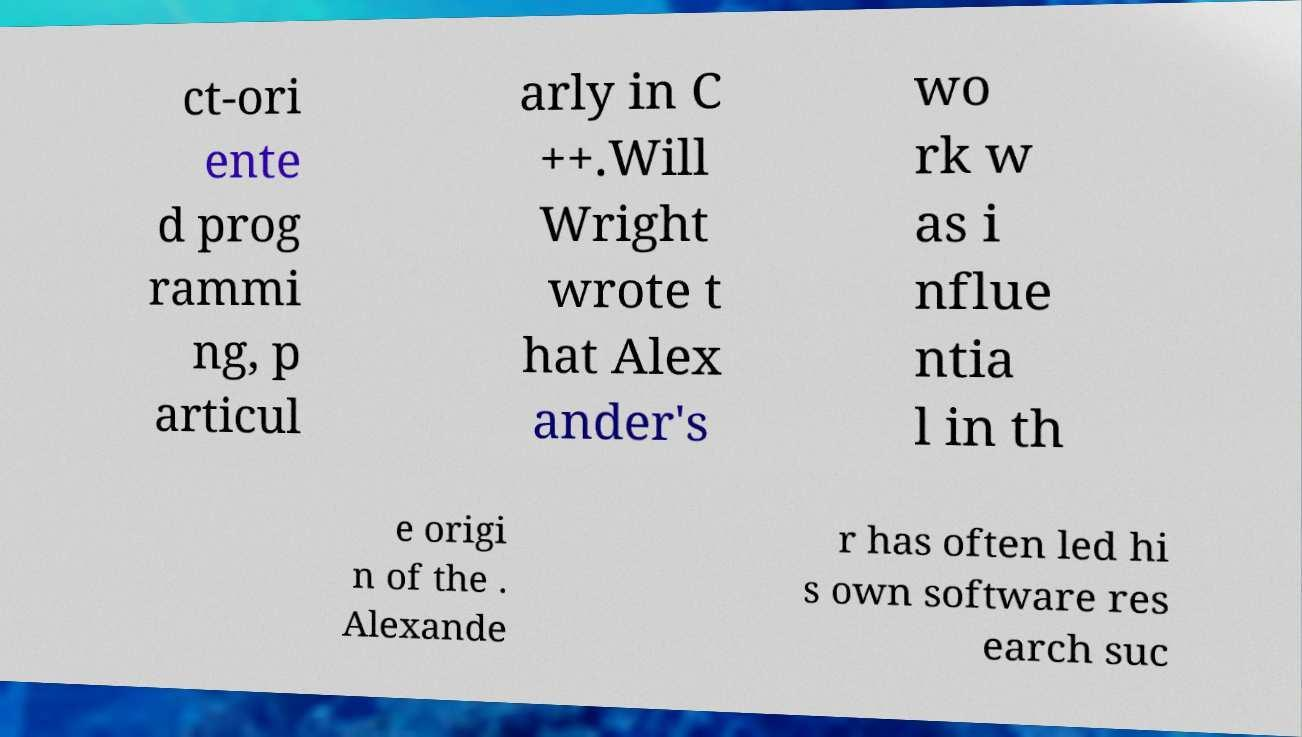Can you accurately transcribe the text from the provided image for me? ct-ori ente d prog rammi ng, p articul arly in C ++.Will Wright wrote t hat Alex ander's wo rk w as i nflue ntia l in th e origi n of the . Alexande r has often led hi s own software res earch suc 